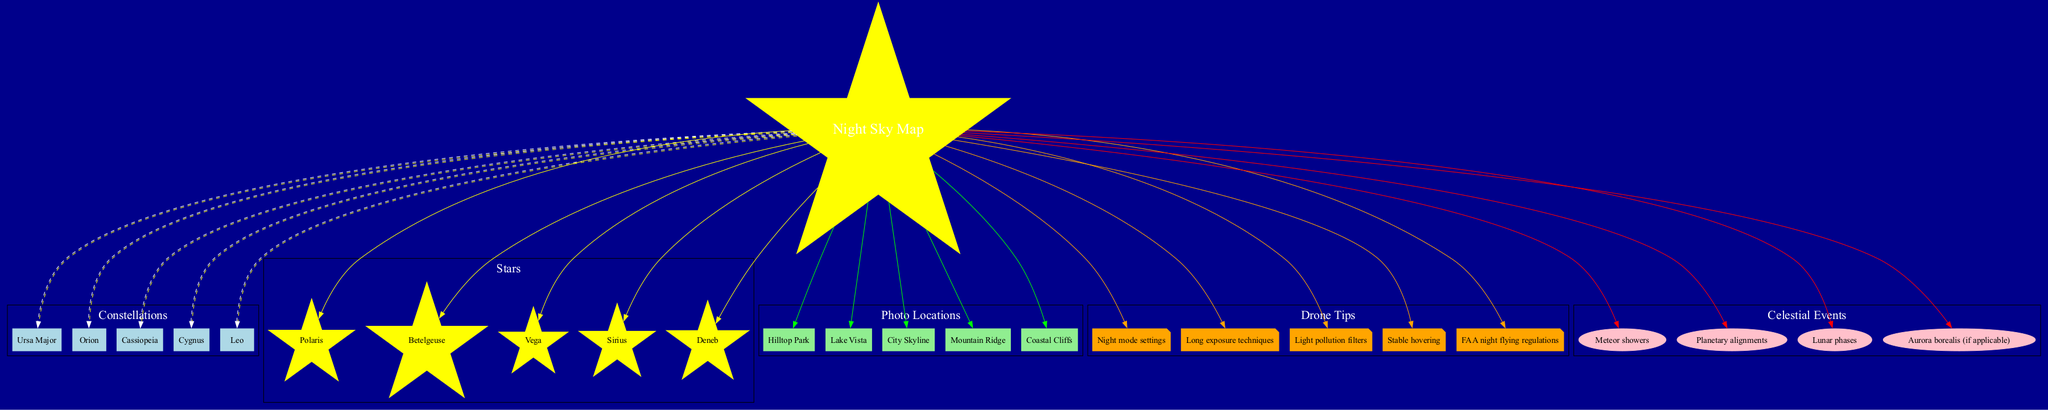What are the highlighted constellations in the diagram? The constellations listed in the diagram are Ursa Major, Orion, Cassiopeia, Cygnus, and Leo. They are categorized under the label "Constellations" in the diagram, connected to the central node, which is the "Night Sky Map."
Answer: Ursa Major, Orion, Cassiopeia, Cygnus, Leo How many stars are shown in the diagram? The diagram features five stars: Polaris, Betelgeuse, Vega, Sirius, and Deneb. This can be confirmed by counting the nodes listed under the "Stars" section within the diagram.
Answer: 5 What location is indicated for potential aerial photography? The diagram presents several locations for aerial photography, which includes Hilltop Park, Lake Vista, City Skyline, Mountain Ridge, and Coastal Cliffs. This can be seen in the "Photo Locations" section connected to the center node.
Answer: Hilltop Park, Lake Vista, City Skyline, Mountain Ridge, Coastal Cliffs What drone tip suggests dealing with light pollution? Among the drone tips listed in the diagram, "Light pollution filters" is specifically focused on addressing light pollution concerns while capturing photographs at night. This tip is part of the "Drone Tips" section.
Answer: Light pollution filters Which star is marked as the brightest in the night sky? The star labeled as the brightest in the diagram is "Sirius." It is one of the stars listed in the "Stars" section and can be identified visually by its prominence among the other stars mentioned.
Answer: Sirius Name the potential celestial event related to multiple occurrences. The diagram mentions "Meteor showers" as a potential celestial event that happens multiple times throughout the year, implying it is a recurring event. This falls under the "Celestial Events" section of the diagram.
Answer: Meteor showers How many categories are shown in the diagram? The diagram categorizes the information into five distinct sections: Constellations, Stars, Photo Locations, Drone Tips, and Celestial Events. These sections are represented as node clusters connected to the main "Night Sky Map" center.
Answer: 5 Which constellation is known for its characteristic shape resembling a 'W'? The diagram includes "Cassiopeia" among the constellations, which is commonly recognized for its distinct 'W' shape in the night sky. This can be confirmed by its position in the "Constellations" section.
Answer: Cassiopeia 